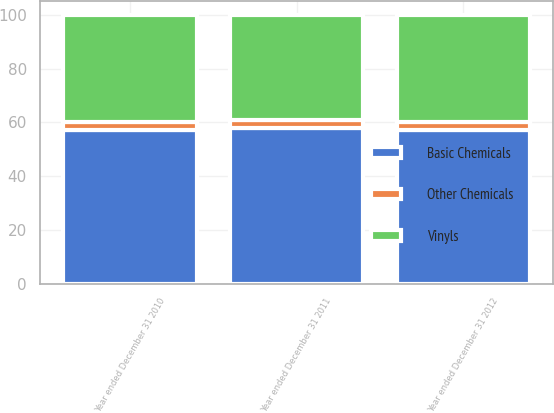Convert chart to OTSL. <chart><loc_0><loc_0><loc_500><loc_500><stacked_bar_chart><ecel><fcel>Year ended December 31 2012<fcel>Year ended December 31 2011<fcel>Year ended December 31 2010<nl><fcel>Basic Chemicals<fcel>57<fcel>58<fcel>57<nl><fcel>Vinyls<fcel>40<fcel>39<fcel>40<nl><fcel>Other Chemicals<fcel>3<fcel>3<fcel>3<nl></chart> 